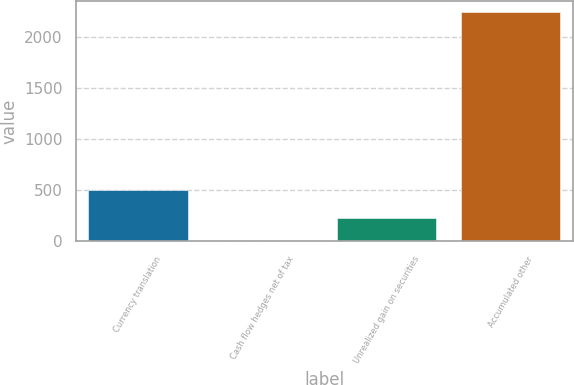Convert chart to OTSL. <chart><loc_0><loc_0><loc_500><loc_500><bar_chart><fcel>Currency translation<fcel>Cash flow hedges net of tax<fcel>Unrealized gain on securities<fcel>Accumulated other<nl><fcel>506<fcel>4<fcel>228.2<fcel>2246<nl></chart> 